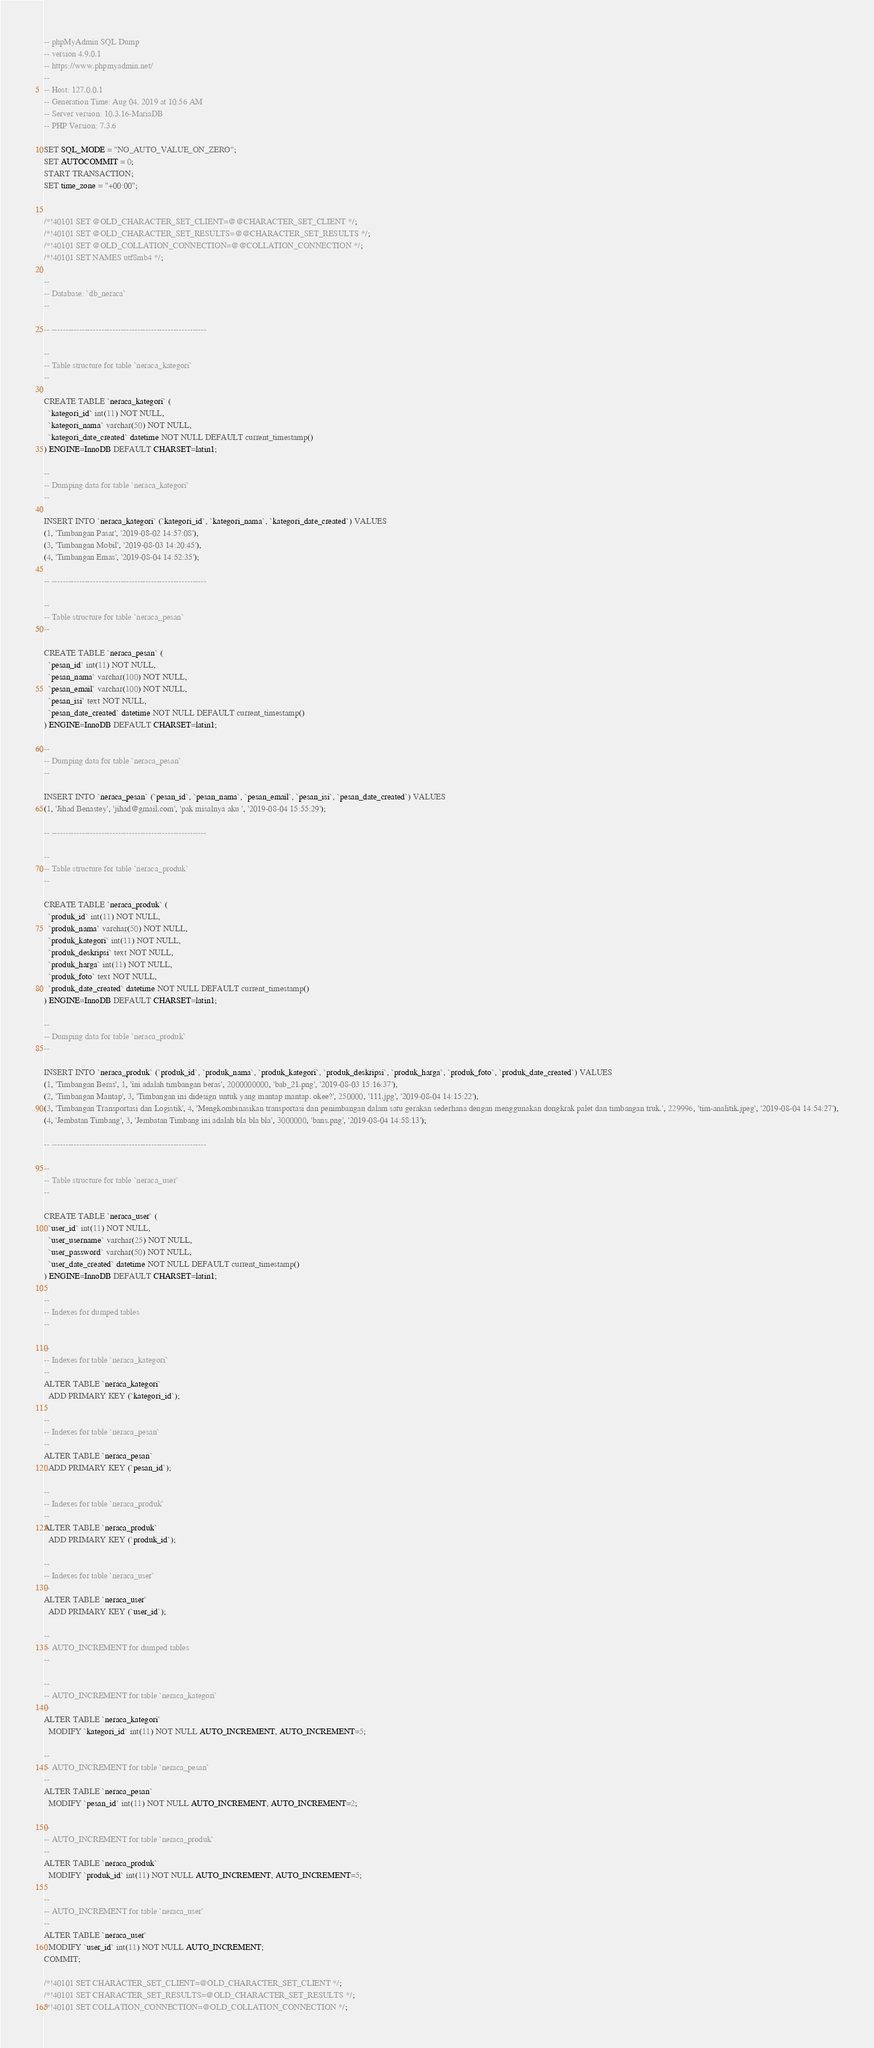<code> <loc_0><loc_0><loc_500><loc_500><_SQL_>-- phpMyAdmin SQL Dump
-- version 4.9.0.1
-- https://www.phpmyadmin.net/
--
-- Host: 127.0.0.1
-- Generation Time: Aug 04, 2019 at 10:56 AM
-- Server version: 10.3.16-MariaDB
-- PHP Version: 7.3.6

SET SQL_MODE = "NO_AUTO_VALUE_ON_ZERO";
SET AUTOCOMMIT = 0;
START TRANSACTION;
SET time_zone = "+00:00";


/*!40101 SET @OLD_CHARACTER_SET_CLIENT=@@CHARACTER_SET_CLIENT */;
/*!40101 SET @OLD_CHARACTER_SET_RESULTS=@@CHARACTER_SET_RESULTS */;
/*!40101 SET @OLD_COLLATION_CONNECTION=@@COLLATION_CONNECTION */;
/*!40101 SET NAMES utf8mb4 */;

--
-- Database: `db_neraca`
--

-- --------------------------------------------------------

--
-- Table structure for table `neraca_kategori`
--

CREATE TABLE `neraca_kategori` (
  `kategori_id` int(11) NOT NULL,
  `kategori_nama` varchar(50) NOT NULL,
  `kategori_date_created` datetime NOT NULL DEFAULT current_timestamp()
) ENGINE=InnoDB DEFAULT CHARSET=latin1;

--
-- Dumping data for table `neraca_kategori`
--

INSERT INTO `neraca_kategori` (`kategori_id`, `kategori_nama`, `kategori_date_created`) VALUES
(1, 'Timbangan Pasar', '2019-08-02 14:57:08'),
(3, 'Timbangan Mobil', '2019-08-03 14:20:45'),
(4, 'Timbangan Emas', '2019-08-04 14:52:35');

-- --------------------------------------------------------

--
-- Table structure for table `neraca_pesan`
--

CREATE TABLE `neraca_pesan` (
  `pesan_id` int(11) NOT NULL,
  `pesan_nama` varchar(100) NOT NULL,
  `pesan_email` varchar(100) NOT NULL,
  `pesan_isi` text NOT NULL,
  `pesan_date_created` datetime NOT NULL DEFAULT current_timestamp()
) ENGINE=InnoDB DEFAULT CHARSET=latin1;

--
-- Dumping data for table `neraca_pesan`
--

INSERT INTO `neraca_pesan` (`pesan_id`, `pesan_nama`, `pesan_email`, `pesan_isi`, `pesan_date_created`) VALUES
(1, 'Jihad Benastey', 'jihad@gmail.com', 'pak misalnya aku ', '2019-08-04 15:55:29');

-- --------------------------------------------------------

--
-- Table structure for table `neraca_produk`
--

CREATE TABLE `neraca_produk` (
  `produk_id` int(11) NOT NULL,
  `produk_nama` varchar(50) NOT NULL,
  `produk_kategori` int(11) NOT NULL,
  `produk_deskripsi` text NOT NULL,
  `produk_harga` int(11) NOT NULL,
  `produk_foto` text NOT NULL,
  `produk_date_created` datetime NOT NULL DEFAULT current_timestamp()
) ENGINE=InnoDB DEFAULT CHARSET=latin1;

--
-- Dumping data for table `neraca_produk`
--

INSERT INTO `neraca_produk` (`produk_id`, `produk_nama`, `produk_kategori`, `produk_deskripsi`, `produk_harga`, `produk_foto`, `produk_date_created`) VALUES
(1, 'Timbangan Beras', 1, 'ini adalah timbangan beras', 2000000000, 'bab_21.png', '2019-08-03 15:16:37'),
(2, 'Timbangan Mantap', 3, 'Timbangan ini didesign untuk yang mantap mantap. okee?', 250000, '111.jpg', '2019-08-04 14:15:22'),
(3, 'Timbangan Transportasi dan Logistik', 4, 'Mengkombinasikan transportasi dan penimbangan dalam satu gerakan sederhana dengan menggunakan dongkrak palet dan timbangan truk.', 229996, 'tim-analitik.jpeg', '2019-08-04 14:54:27'),
(4, 'Jembatan Timbang', 3, 'Jembatan Timbang ini adalah bla bla bla', 3000000, 'bans.png', '2019-08-04 14:58:13');

-- --------------------------------------------------------

--
-- Table structure for table `neraca_user`
--

CREATE TABLE `neraca_user` (
  `user_id` int(11) NOT NULL,
  `user_username` varchar(25) NOT NULL,
  `user_password` varchar(50) NOT NULL,
  `user_date_created` datetime NOT NULL DEFAULT current_timestamp()
) ENGINE=InnoDB DEFAULT CHARSET=latin1;

--
-- Indexes for dumped tables
--

--
-- Indexes for table `neraca_kategori`
--
ALTER TABLE `neraca_kategori`
  ADD PRIMARY KEY (`kategori_id`);

--
-- Indexes for table `neraca_pesan`
--
ALTER TABLE `neraca_pesan`
  ADD PRIMARY KEY (`pesan_id`);

--
-- Indexes for table `neraca_produk`
--
ALTER TABLE `neraca_produk`
  ADD PRIMARY KEY (`produk_id`);

--
-- Indexes for table `neraca_user`
--
ALTER TABLE `neraca_user`
  ADD PRIMARY KEY (`user_id`);

--
-- AUTO_INCREMENT for dumped tables
--

--
-- AUTO_INCREMENT for table `neraca_kategori`
--
ALTER TABLE `neraca_kategori`
  MODIFY `kategori_id` int(11) NOT NULL AUTO_INCREMENT, AUTO_INCREMENT=5;

--
-- AUTO_INCREMENT for table `neraca_pesan`
--
ALTER TABLE `neraca_pesan`
  MODIFY `pesan_id` int(11) NOT NULL AUTO_INCREMENT, AUTO_INCREMENT=2;

--
-- AUTO_INCREMENT for table `neraca_produk`
--
ALTER TABLE `neraca_produk`
  MODIFY `produk_id` int(11) NOT NULL AUTO_INCREMENT, AUTO_INCREMENT=5;

--
-- AUTO_INCREMENT for table `neraca_user`
--
ALTER TABLE `neraca_user`
  MODIFY `user_id` int(11) NOT NULL AUTO_INCREMENT;
COMMIT;

/*!40101 SET CHARACTER_SET_CLIENT=@OLD_CHARACTER_SET_CLIENT */;
/*!40101 SET CHARACTER_SET_RESULTS=@OLD_CHARACTER_SET_RESULTS */;
/*!40101 SET COLLATION_CONNECTION=@OLD_COLLATION_CONNECTION */;
</code> 